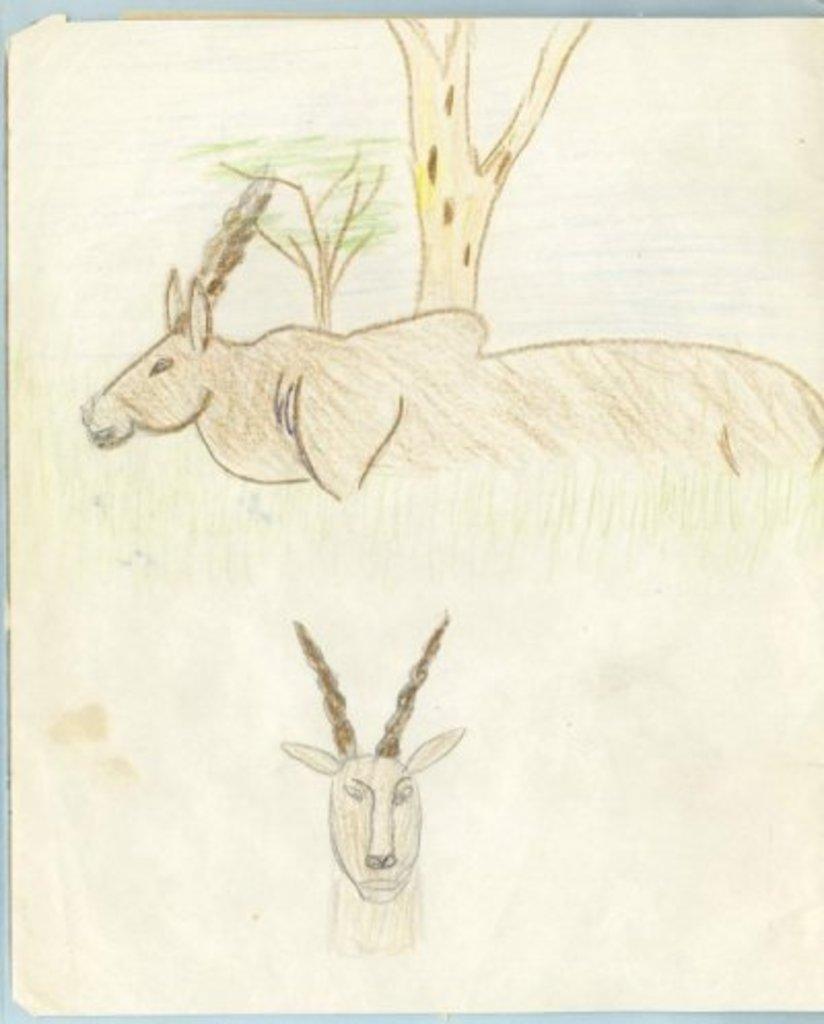Please provide a concise description of this image. In this image we can see drawing of two animals. In the background, we can some trees. 